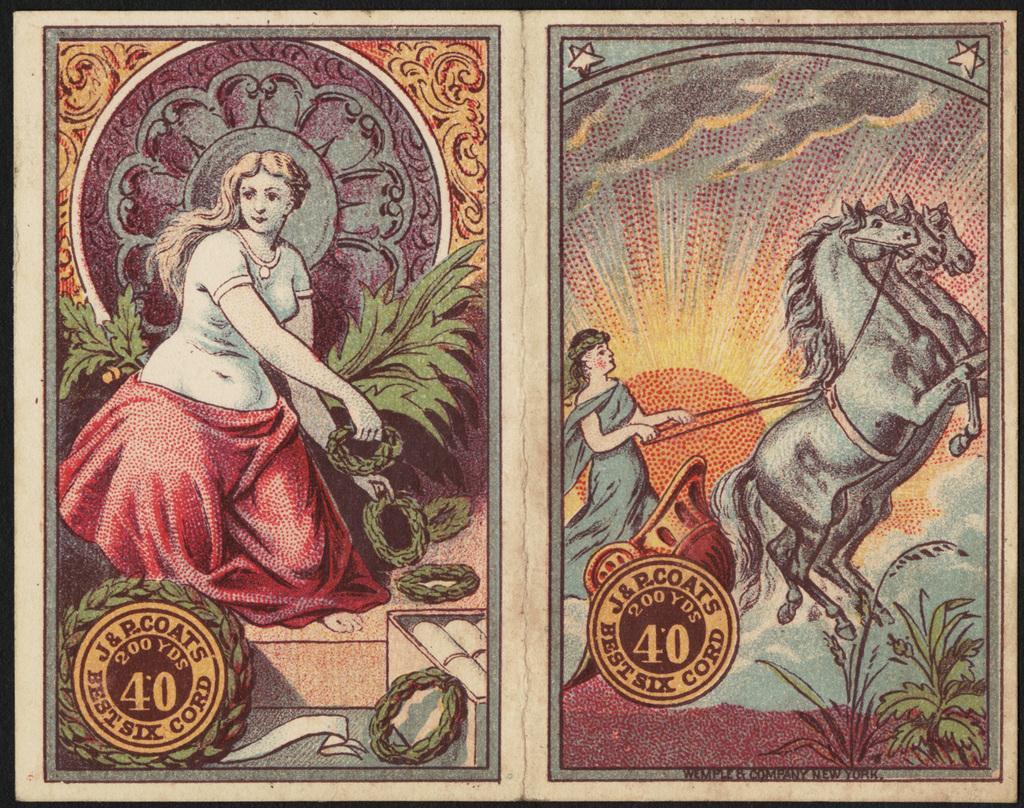Can you describe this image briefly? In this picture there is one frame with two different pictures. In the first picture, there is a woman holding rings. On her, there is a red cloth. In the second picture, there is another woman riding the horse-cart. In the background there is a sun. 